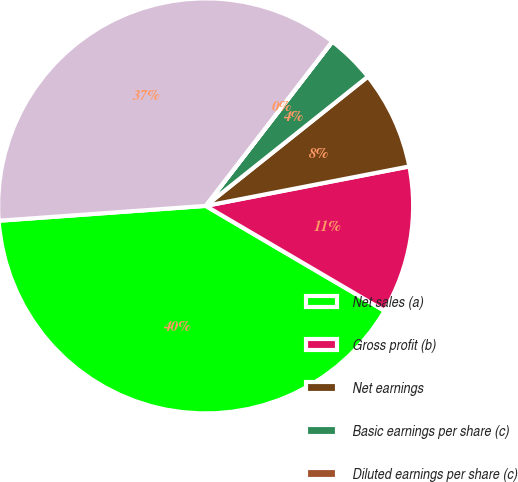<chart> <loc_0><loc_0><loc_500><loc_500><pie_chart><fcel>Net sales (a)<fcel>Gross profit (b)<fcel>Net earnings<fcel>Basic earnings per share (c)<fcel>Diluted earnings per share (c)<fcel>Net sales<nl><fcel>40.41%<fcel>11.49%<fcel>7.66%<fcel>3.84%<fcel>0.01%<fcel>36.58%<nl></chart> 